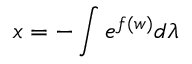<formula> <loc_0><loc_0><loc_500><loc_500>x = - \int e ^ { f ( w ) } d \lambda</formula> 